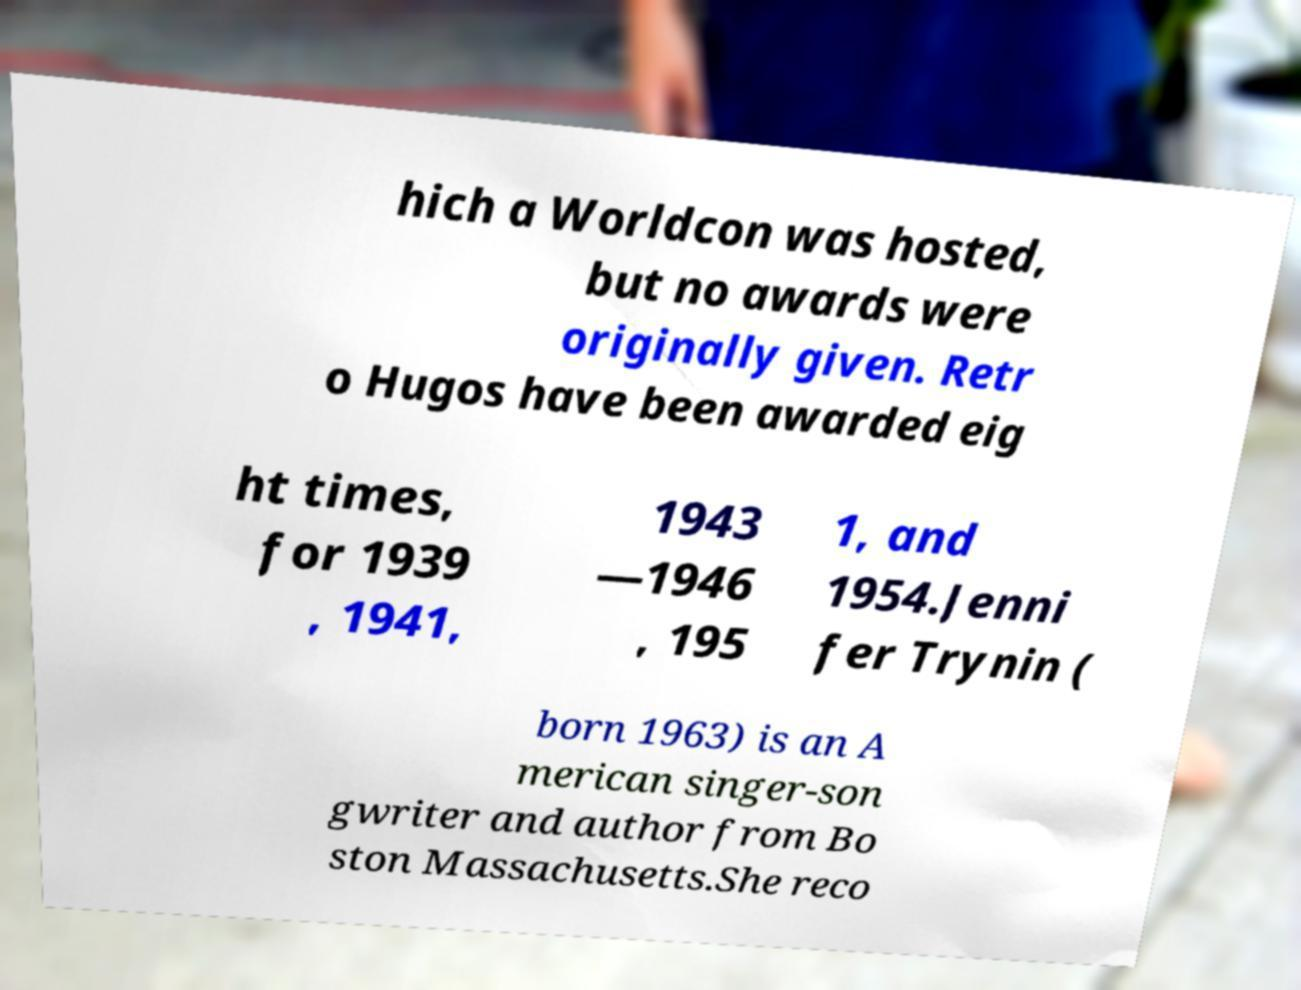I need the written content from this picture converted into text. Can you do that? hich a Worldcon was hosted, but no awards were originally given. Retr o Hugos have been awarded eig ht times, for 1939 , 1941, 1943 —1946 , 195 1, and 1954.Jenni fer Trynin ( born 1963) is an A merican singer-son gwriter and author from Bo ston Massachusetts.She reco 